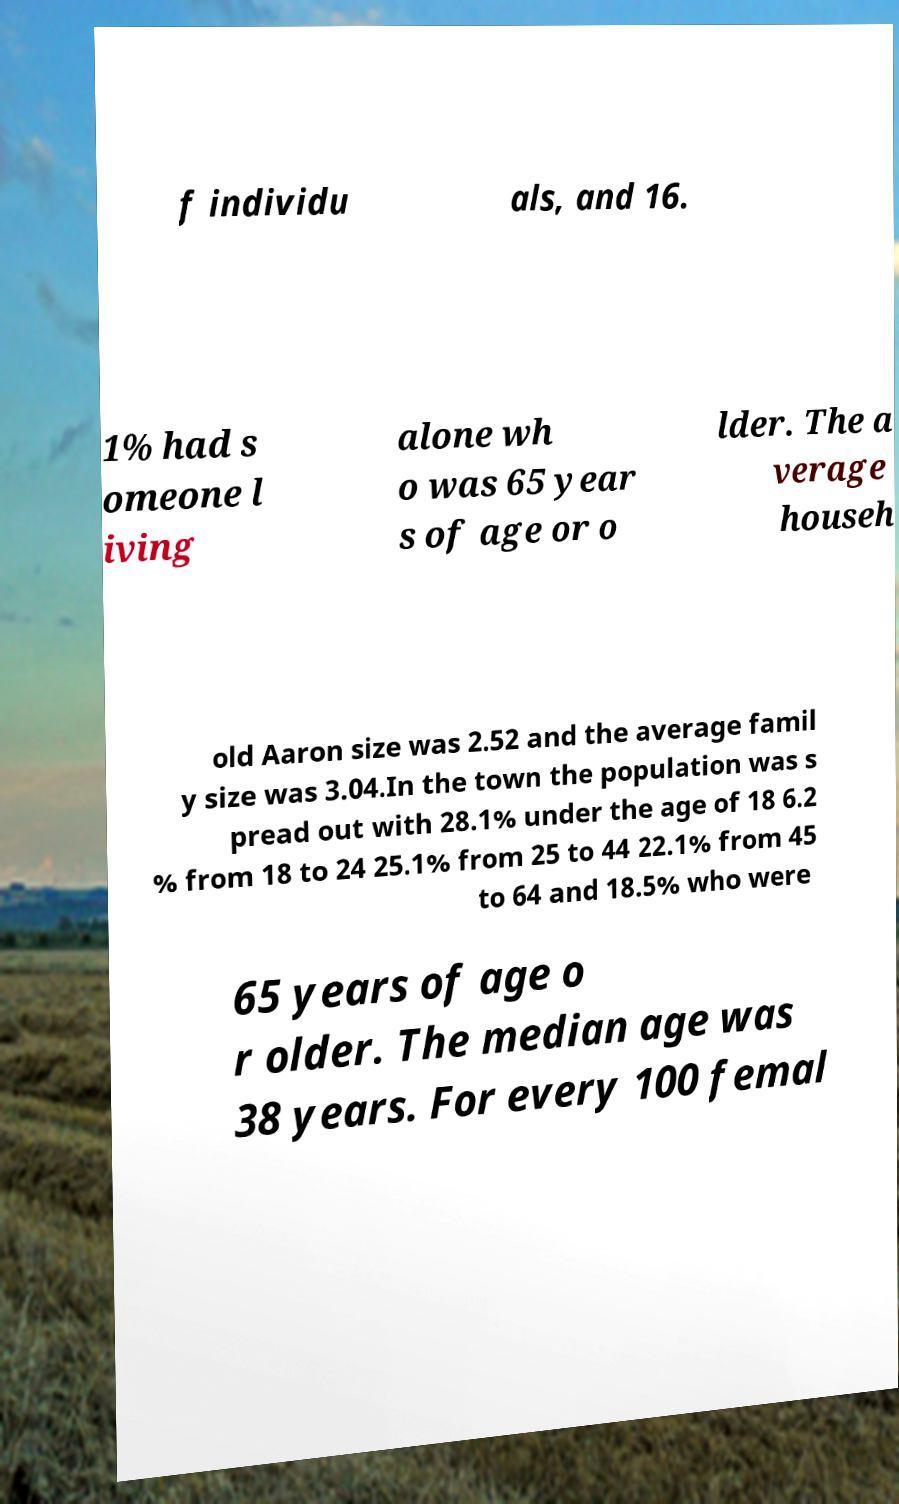There's text embedded in this image that I need extracted. Can you transcribe it verbatim? f individu als, and 16. 1% had s omeone l iving alone wh o was 65 year s of age or o lder. The a verage househ old Aaron size was 2.52 and the average famil y size was 3.04.In the town the population was s pread out with 28.1% under the age of 18 6.2 % from 18 to 24 25.1% from 25 to 44 22.1% from 45 to 64 and 18.5% who were 65 years of age o r older. The median age was 38 years. For every 100 femal 